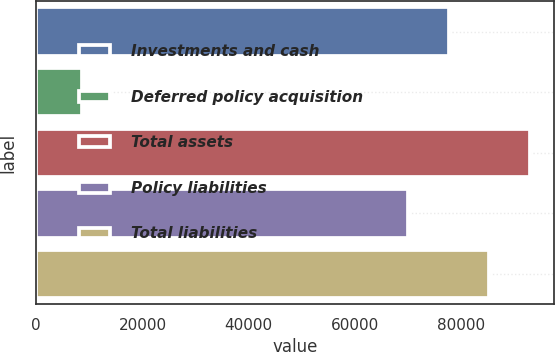Convert chart to OTSL. <chart><loc_0><loc_0><loc_500><loc_500><bar_chart><fcel>Investments and cash<fcel>Deferred policy acquisition<fcel>Total assets<fcel>Policy liabilities<fcel>Total liabilities<nl><fcel>77604.3<fcel>8602<fcel>92864.9<fcel>69974<fcel>85234.6<nl></chart> 